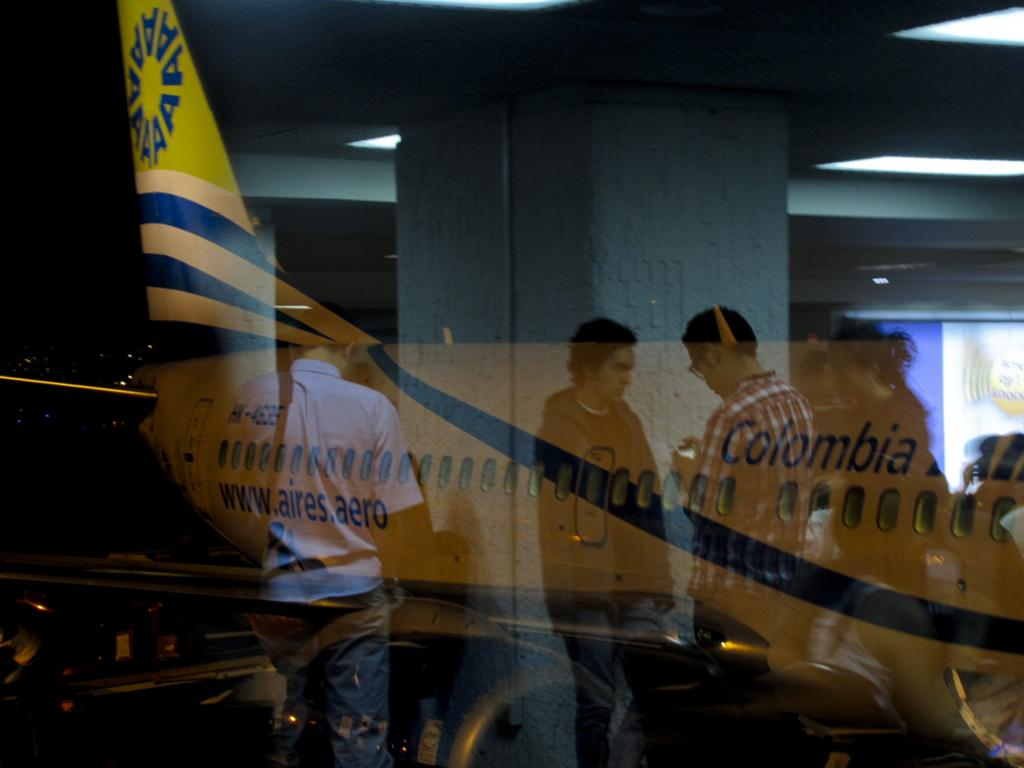What can be seen reflected on the glass in the image? There is a reflection of an airplane and reflections of people on the glass. What other object is present in the image? There is a pillar in the image. What type of calendar is hanging on the pillar in the image? There is no calendar present in the image; the conversation focuses on the reflections on the glass and the pillar. 